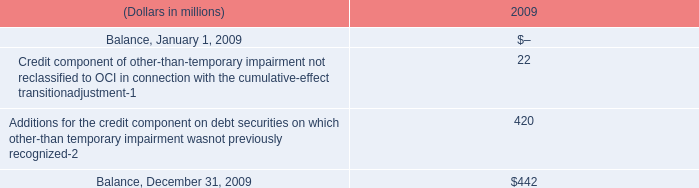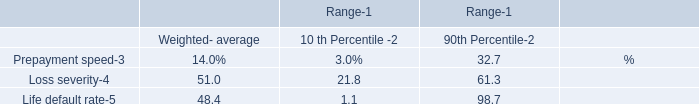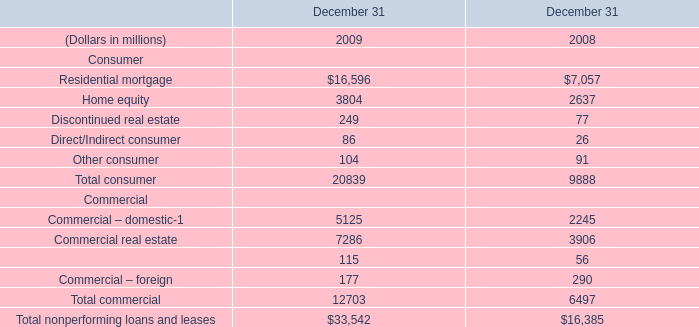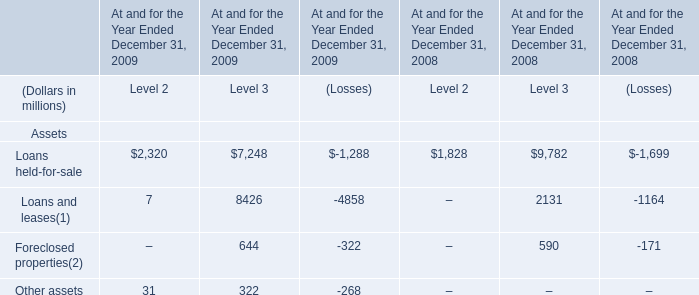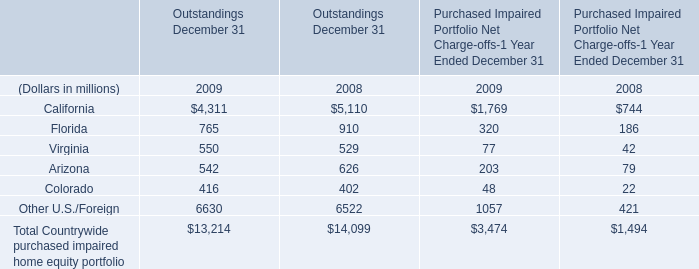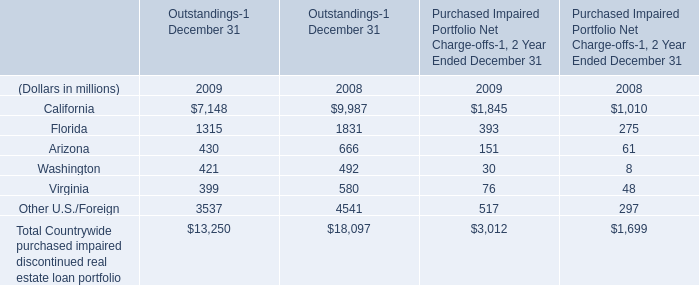What will California of outstandings be like in 2010 if it develops with the same increasing rate as current? (in millions) 
Computations: ((1 + ((7148 - 9987) / 9987)) * 7148)
Answer: 5116.04125. 